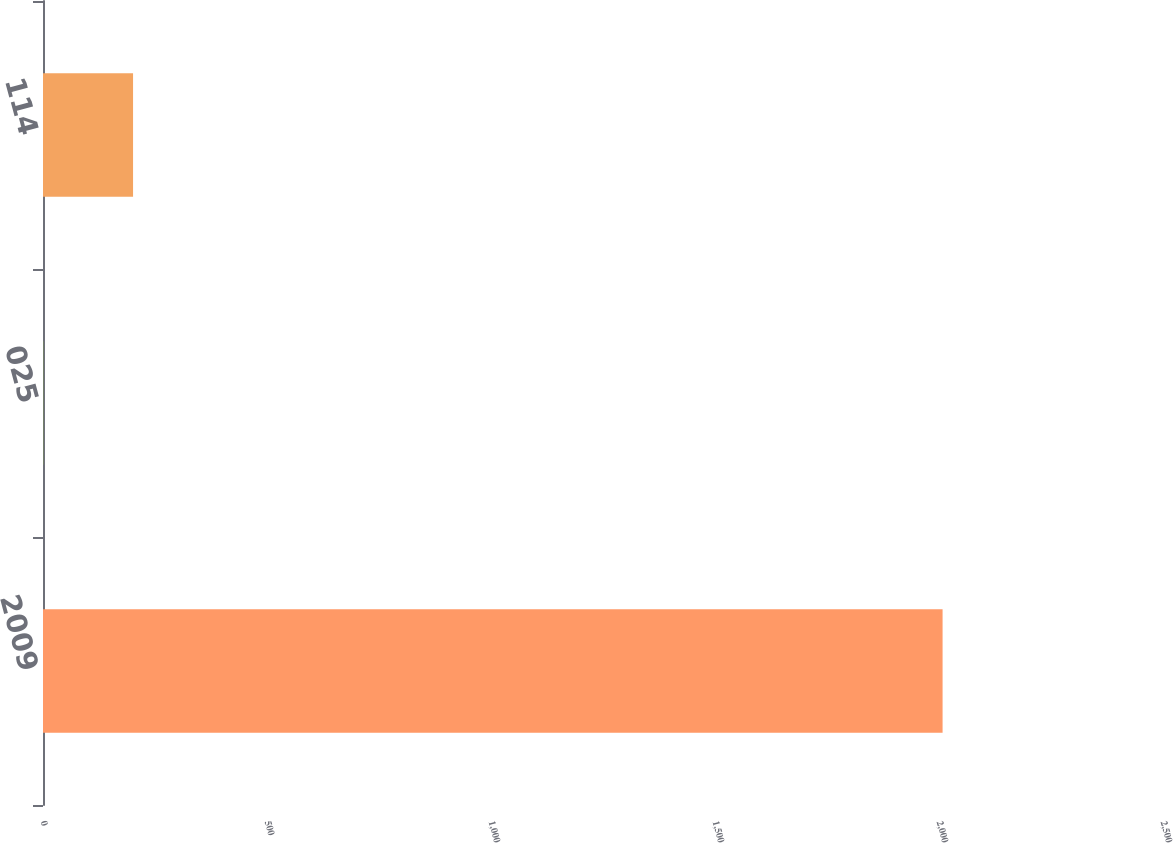Convert chart to OTSL. <chart><loc_0><loc_0><loc_500><loc_500><bar_chart><fcel>2009<fcel>025<fcel>114<nl><fcel>2008<fcel>0.25<fcel>201.03<nl></chart> 